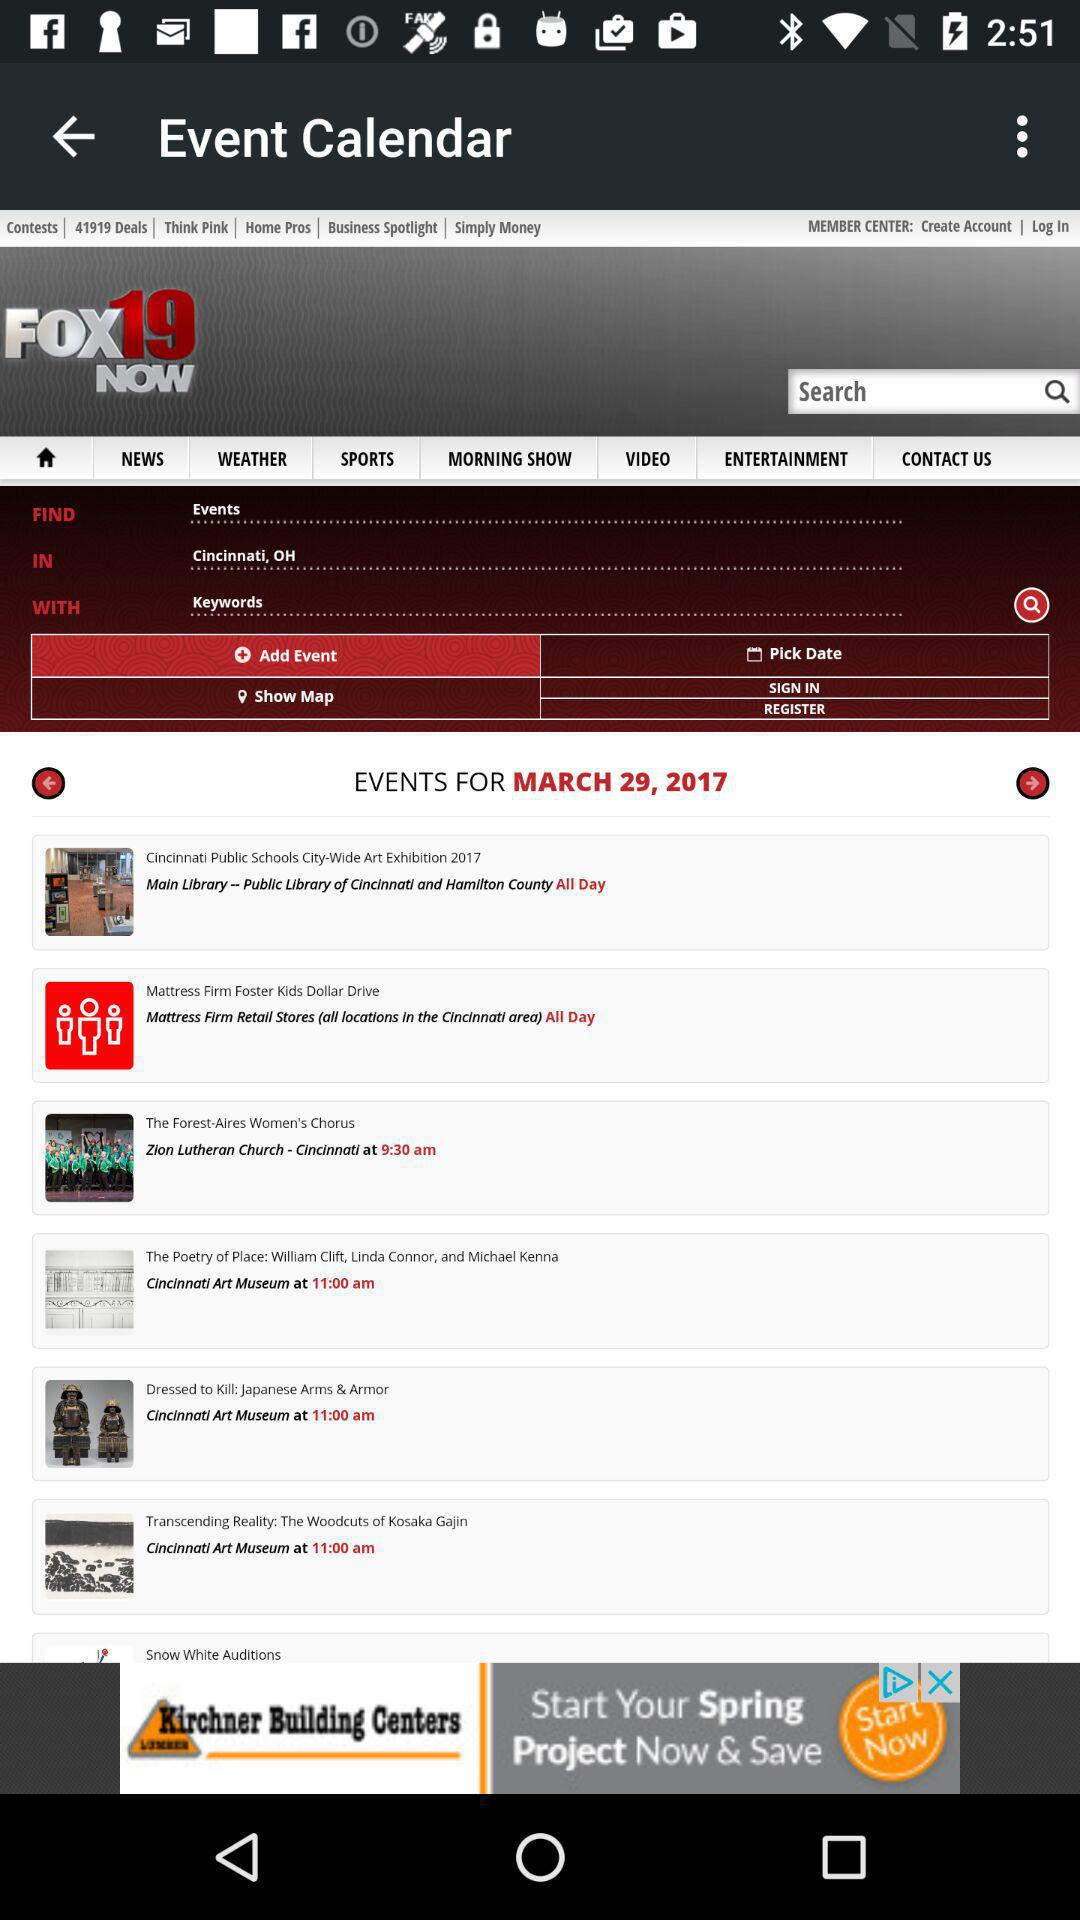What date's events are shown? The date is March 29, 2017. 